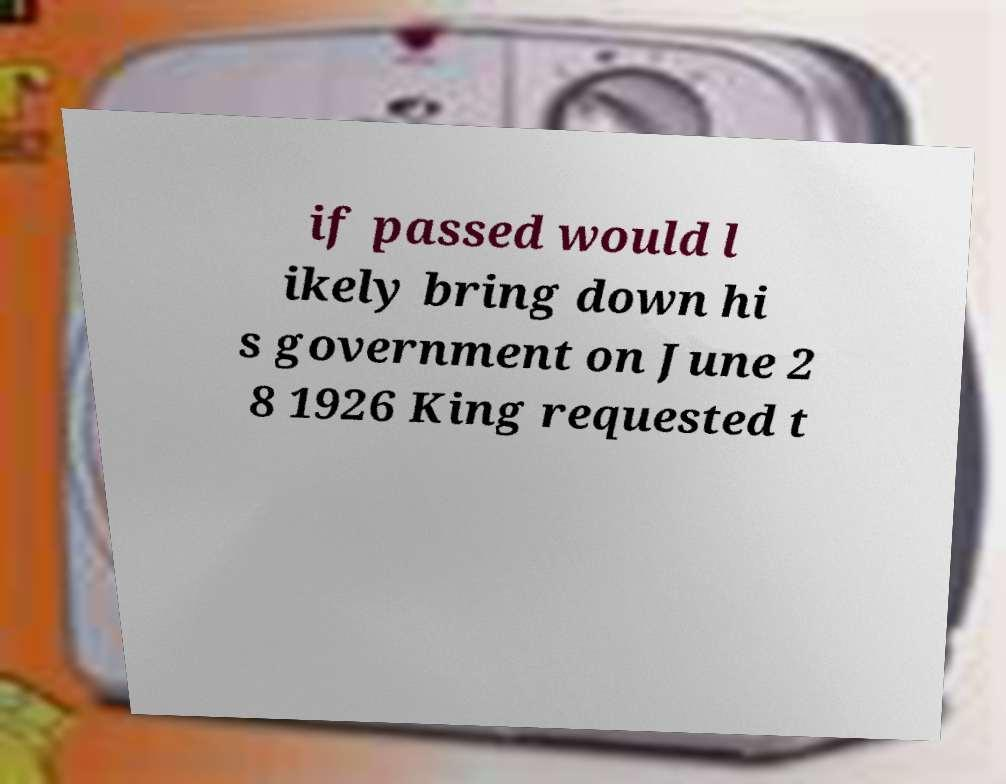What messages or text are displayed in this image? I need them in a readable, typed format. if passed would l ikely bring down hi s government on June 2 8 1926 King requested t 